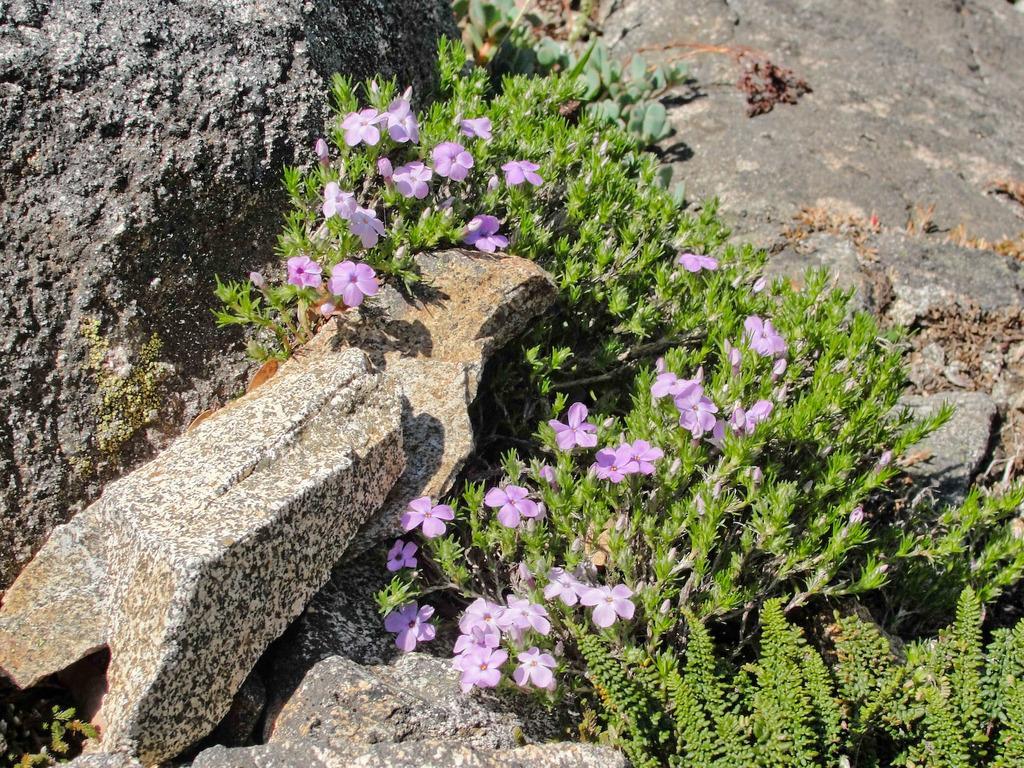Could you give a brief overview of what you see in this image? In this picture we can see some plants where, there are some flowers and leaves here, on the left side we can see a rock. 